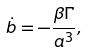<formula> <loc_0><loc_0><loc_500><loc_500>\dot { b } = - \frac { \beta \Gamma } { a ^ { 3 } } ,</formula> 